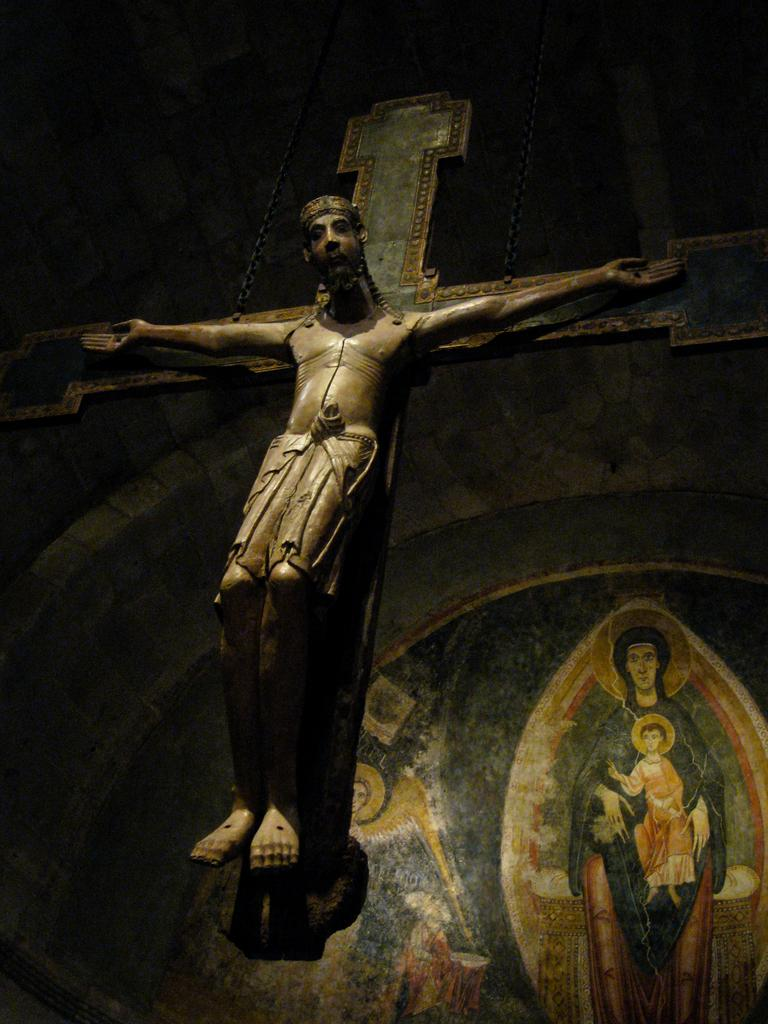What is the main subject of the statue in the image? The main subject of the statue in the image is Jesus. What can be seen on the wall in the image? There is a painting on the wall in the image. What type of weather can be seen in the image? There is no weather depicted in the image, as it features a statue of Jesus and a painting on the wall. Can you describe the curve of the goose in the image? There is no goose present in the image, so it is not possible to describe its curve. 